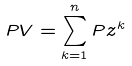Convert formula to latex. <formula><loc_0><loc_0><loc_500><loc_500>P V = \sum _ { k = 1 } ^ { n } P z ^ { k }</formula> 